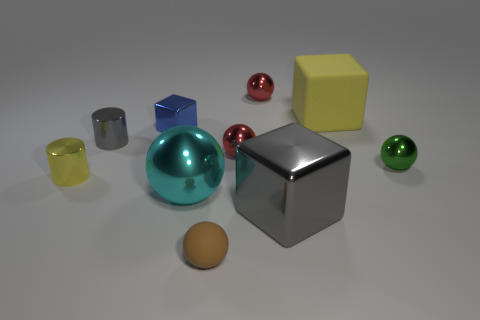Subtract all cyan balls. How many balls are left? 4 Subtract all brown rubber spheres. How many spheres are left? 4 Subtract all brown spheres. Subtract all gray cylinders. How many spheres are left? 4 Subtract all cubes. How many objects are left? 7 Add 3 big gray metal cubes. How many big gray metal cubes are left? 4 Add 9 large yellow matte cubes. How many large yellow matte cubes exist? 10 Subtract 1 yellow blocks. How many objects are left? 9 Subtract all tiny gray objects. Subtract all matte cubes. How many objects are left? 8 